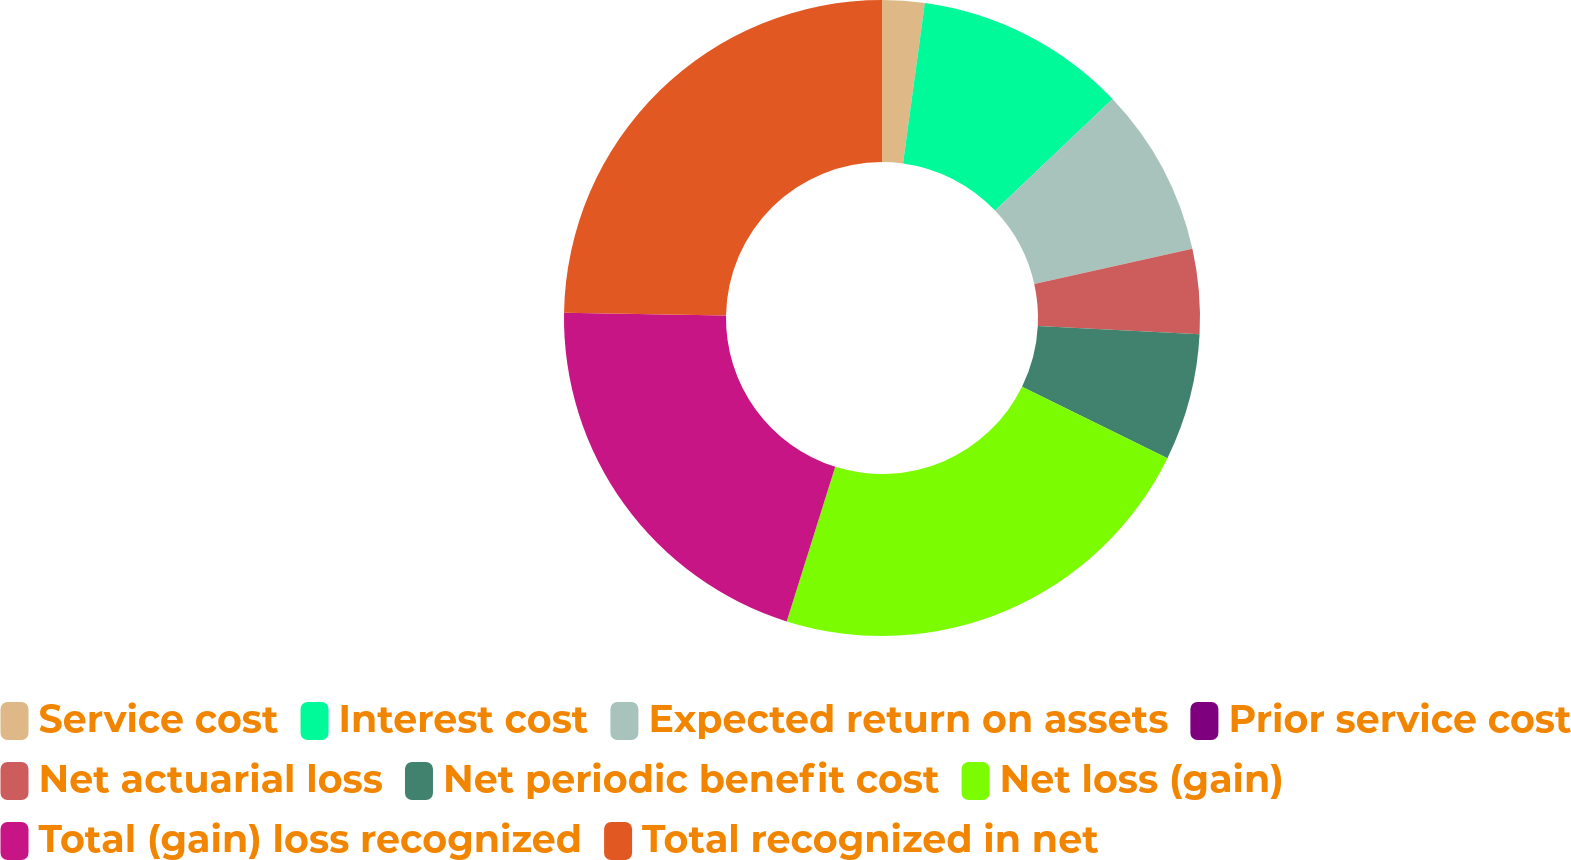<chart> <loc_0><loc_0><loc_500><loc_500><pie_chart><fcel>Service cost<fcel>Interest cost<fcel>Expected return on assets<fcel>Prior service cost<fcel>Net actuarial loss<fcel>Net periodic benefit cost<fcel>Net loss (gain)<fcel>Total (gain) loss recognized<fcel>Total recognized in net<nl><fcel>2.15%<fcel>10.76%<fcel>8.6%<fcel>0.0%<fcel>4.3%<fcel>6.45%<fcel>22.58%<fcel>20.42%<fcel>24.73%<nl></chart> 